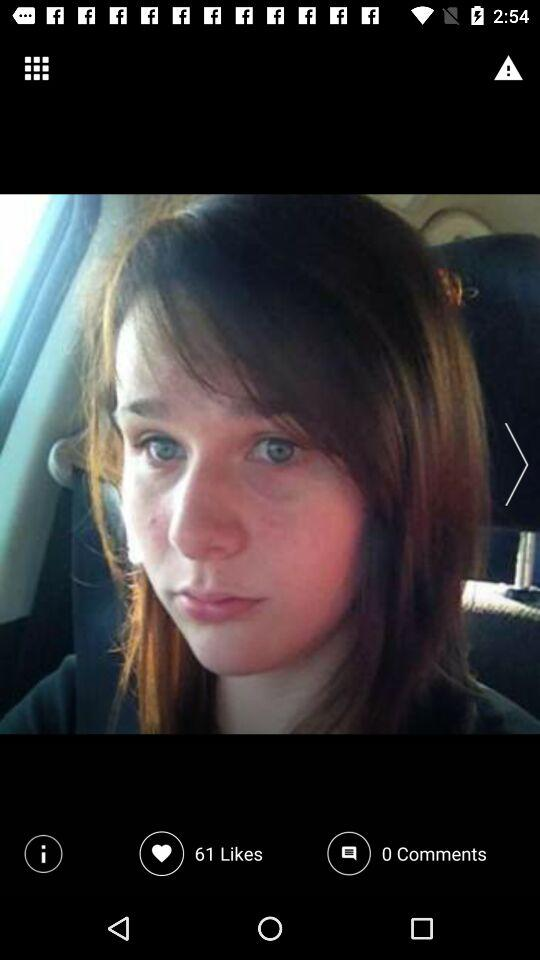What is the count of comments? The count of comments is 0. 